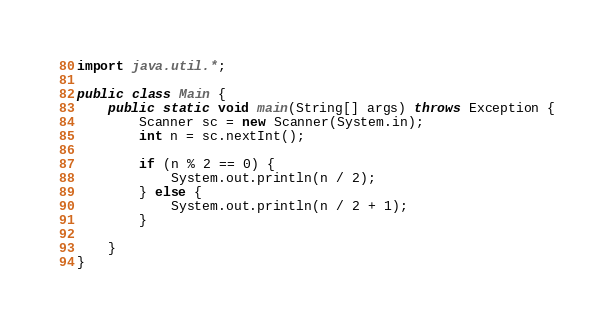Convert code to text. <code><loc_0><loc_0><loc_500><loc_500><_Java_>import java.util.*;

public class Main {
    public static void main(String[] args) throws Exception {
        Scanner sc = new Scanner(System.in);
        int n = sc.nextInt();

        if (n % 2 == 0) {
            System.out.println(n / 2);
        } else {
            System.out.println(n / 2 + 1);
        }

    }
}
</code> 